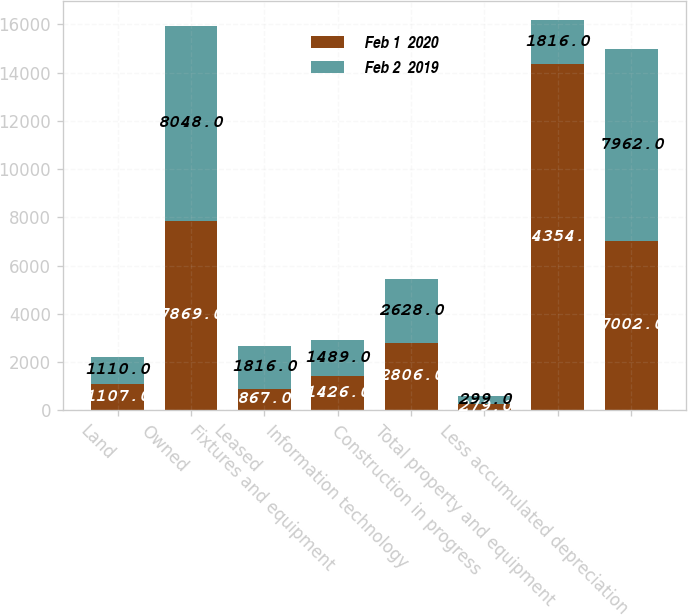Convert chart. <chart><loc_0><loc_0><loc_500><loc_500><stacked_bar_chart><ecel><fcel>Land<fcel>Owned<fcel>Leased<fcel>Fixtures and equipment<fcel>Information technology<fcel>Construction in progress<fcel>Total property and equipment<fcel>Less accumulated depreciation<nl><fcel>Feb 1  2020<fcel>1107<fcel>7869<fcel>867<fcel>1426<fcel>2806<fcel>279<fcel>14354<fcel>7002<nl><fcel>Feb 2  2019<fcel>1110<fcel>8048<fcel>1816<fcel>1489<fcel>2628<fcel>299<fcel>1816<fcel>7962<nl></chart> 